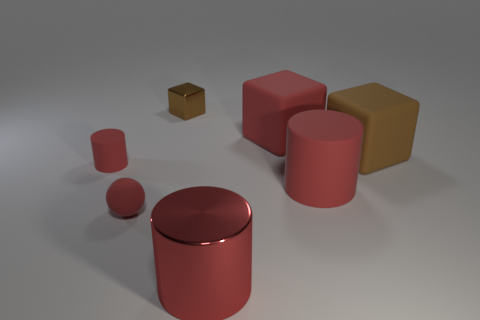What is the size of the cube that is the same color as the metal cylinder?
Provide a succinct answer. Large. There is a large block that is the same color as the rubber sphere; what material is it?
Ensure brevity in your answer.  Rubber. Is the color of the cylinder on the left side of the small brown shiny cube the same as the small metal thing that is behind the big brown block?
Keep it short and to the point. No. What shape is the brown thing on the left side of the big red matte thing that is behind the rubber cylinder left of the small rubber ball?
Your answer should be very brief. Cube. There is a red rubber object that is on the right side of the small red ball and behind the large matte cylinder; what is its shape?
Your response must be concise. Cube. How many red things are on the right side of the metallic thing that is behind the red cylinder that is in front of the tiny red sphere?
Provide a short and direct response. 3. There is a red rubber thing that is the same shape as the brown matte thing; what size is it?
Ensure brevity in your answer.  Large. Is there any other thing that is the same size as the brown matte thing?
Keep it short and to the point. Yes. Is the tiny object that is on the right side of the tiny red sphere made of the same material as the large brown block?
Your answer should be very brief. No. The other large thing that is the same shape as the large red metal object is what color?
Give a very brief answer. Red. 